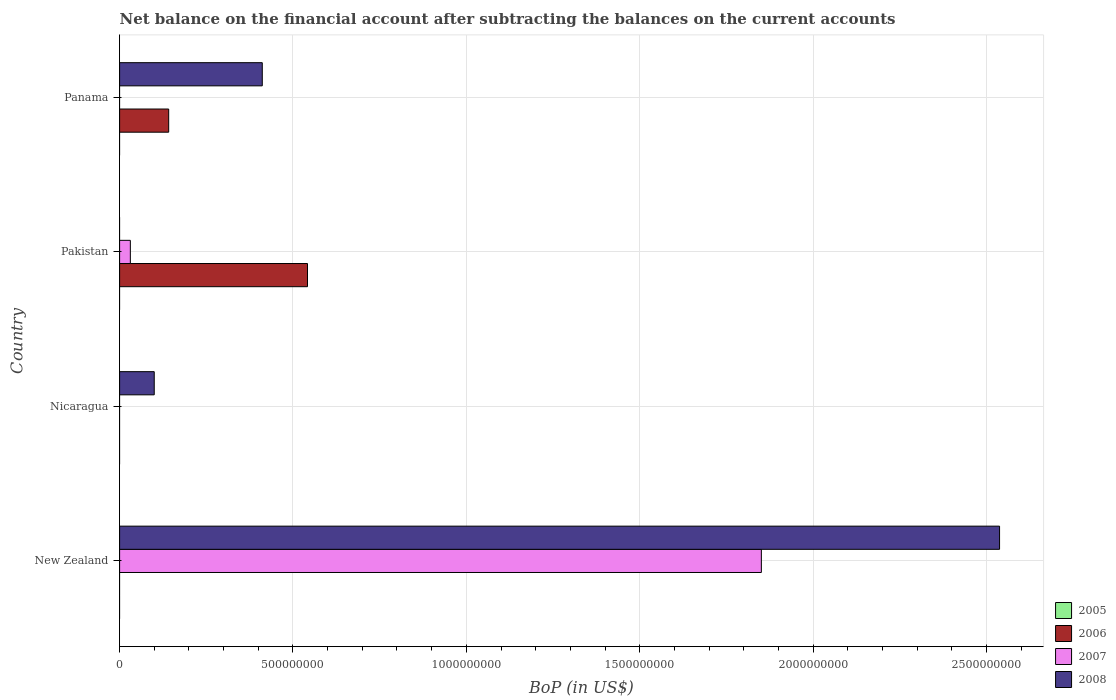How many bars are there on the 2nd tick from the top?
Keep it short and to the point. 2. What is the label of the 4th group of bars from the top?
Give a very brief answer. New Zealand. In how many cases, is the number of bars for a given country not equal to the number of legend labels?
Ensure brevity in your answer.  4. What is the Balance of Payments in 2006 in Nicaragua?
Keep it short and to the point. 0. Across all countries, what is the maximum Balance of Payments in 2007?
Offer a very short reply. 1.85e+09. In which country was the Balance of Payments in 2007 maximum?
Your answer should be compact. New Zealand. What is the total Balance of Payments in 2007 in the graph?
Provide a succinct answer. 1.88e+09. What is the difference between the Balance of Payments in 2006 in Pakistan and that in Panama?
Ensure brevity in your answer.  4.00e+08. What is the difference between the Balance of Payments in 2006 in Panama and the Balance of Payments in 2007 in Pakistan?
Offer a terse response. 1.11e+08. What is the average Balance of Payments in 2008 per country?
Offer a terse response. 7.62e+08. What is the difference between the Balance of Payments in 2007 and Balance of Payments in 2008 in New Zealand?
Provide a succinct answer. -6.87e+08. What is the difference between the highest and the second highest Balance of Payments in 2008?
Make the answer very short. 2.13e+09. What is the difference between the highest and the lowest Balance of Payments in 2008?
Your response must be concise. 2.54e+09. Is it the case that in every country, the sum of the Balance of Payments in 2007 and Balance of Payments in 2008 is greater than the Balance of Payments in 2006?
Ensure brevity in your answer.  No. Are all the bars in the graph horizontal?
Provide a short and direct response. Yes. Are the values on the major ticks of X-axis written in scientific E-notation?
Ensure brevity in your answer.  No. Does the graph contain any zero values?
Offer a terse response. Yes. Does the graph contain grids?
Provide a succinct answer. Yes. What is the title of the graph?
Provide a succinct answer. Net balance on the financial account after subtracting the balances on the current accounts. Does "2005" appear as one of the legend labels in the graph?
Ensure brevity in your answer.  Yes. What is the label or title of the X-axis?
Your answer should be compact. BoP (in US$). What is the BoP (in US$) in 2007 in New Zealand?
Offer a terse response. 1.85e+09. What is the BoP (in US$) in 2008 in New Zealand?
Your answer should be very brief. 2.54e+09. What is the BoP (in US$) in 2005 in Nicaragua?
Keep it short and to the point. 0. What is the BoP (in US$) in 2008 in Nicaragua?
Provide a succinct answer. 9.99e+07. What is the BoP (in US$) in 2005 in Pakistan?
Your answer should be compact. 0. What is the BoP (in US$) in 2006 in Pakistan?
Keep it short and to the point. 5.42e+08. What is the BoP (in US$) in 2007 in Pakistan?
Offer a terse response. 3.10e+07. What is the BoP (in US$) in 2005 in Panama?
Provide a short and direct response. 0. What is the BoP (in US$) of 2006 in Panama?
Offer a terse response. 1.42e+08. What is the BoP (in US$) in 2008 in Panama?
Provide a short and direct response. 4.12e+08. Across all countries, what is the maximum BoP (in US$) in 2006?
Provide a succinct answer. 5.42e+08. Across all countries, what is the maximum BoP (in US$) of 2007?
Offer a terse response. 1.85e+09. Across all countries, what is the maximum BoP (in US$) of 2008?
Provide a succinct answer. 2.54e+09. Across all countries, what is the minimum BoP (in US$) in 2006?
Offer a very short reply. 0. Across all countries, what is the minimum BoP (in US$) of 2007?
Make the answer very short. 0. Across all countries, what is the minimum BoP (in US$) in 2008?
Your answer should be very brief. 0. What is the total BoP (in US$) of 2005 in the graph?
Provide a short and direct response. 0. What is the total BoP (in US$) of 2006 in the graph?
Ensure brevity in your answer.  6.84e+08. What is the total BoP (in US$) of 2007 in the graph?
Provide a succinct answer. 1.88e+09. What is the total BoP (in US$) of 2008 in the graph?
Your answer should be compact. 3.05e+09. What is the difference between the BoP (in US$) of 2008 in New Zealand and that in Nicaragua?
Offer a terse response. 2.44e+09. What is the difference between the BoP (in US$) of 2007 in New Zealand and that in Pakistan?
Your answer should be very brief. 1.82e+09. What is the difference between the BoP (in US$) in 2008 in New Zealand and that in Panama?
Give a very brief answer. 2.13e+09. What is the difference between the BoP (in US$) of 2008 in Nicaragua and that in Panama?
Provide a succinct answer. -3.12e+08. What is the difference between the BoP (in US$) of 2006 in Pakistan and that in Panama?
Offer a very short reply. 4.00e+08. What is the difference between the BoP (in US$) in 2007 in New Zealand and the BoP (in US$) in 2008 in Nicaragua?
Your answer should be very brief. 1.75e+09. What is the difference between the BoP (in US$) of 2007 in New Zealand and the BoP (in US$) of 2008 in Panama?
Provide a succinct answer. 1.44e+09. What is the difference between the BoP (in US$) in 2006 in Pakistan and the BoP (in US$) in 2008 in Panama?
Provide a short and direct response. 1.30e+08. What is the difference between the BoP (in US$) of 2007 in Pakistan and the BoP (in US$) of 2008 in Panama?
Ensure brevity in your answer.  -3.80e+08. What is the average BoP (in US$) in 2006 per country?
Your answer should be compact. 1.71e+08. What is the average BoP (in US$) of 2007 per country?
Ensure brevity in your answer.  4.70e+08. What is the average BoP (in US$) in 2008 per country?
Ensure brevity in your answer.  7.62e+08. What is the difference between the BoP (in US$) in 2007 and BoP (in US$) in 2008 in New Zealand?
Provide a succinct answer. -6.87e+08. What is the difference between the BoP (in US$) of 2006 and BoP (in US$) of 2007 in Pakistan?
Provide a succinct answer. 5.11e+08. What is the difference between the BoP (in US$) of 2006 and BoP (in US$) of 2008 in Panama?
Your answer should be compact. -2.70e+08. What is the ratio of the BoP (in US$) of 2008 in New Zealand to that in Nicaragua?
Your response must be concise. 25.4. What is the ratio of the BoP (in US$) of 2007 in New Zealand to that in Pakistan?
Provide a succinct answer. 59.71. What is the ratio of the BoP (in US$) of 2008 in New Zealand to that in Panama?
Provide a short and direct response. 6.17. What is the ratio of the BoP (in US$) of 2008 in Nicaragua to that in Panama?
Provide a succinct answer. 0.24. What is the ratio of the BoP (in US$) of 2006 in Pakistan to that in Panama?
Offer a very short reply. 3.83. What is the difference between the highest and the second highest BoP (in US$) in 2008?
Offer a very short reply. 2.13e+09. What is the difference between the highest and the lowest BoP (in US$) in 2006?
Provide a succinct answer. 5.42e+08. What is the difference between the highest and the lowest BoP (in US$) in 2007?
Offer a very short reply. 1.85e+09. What is the difference between the highest and the lowest BoP (in US$) in 2008?
Your answer should be very brief. 2.54e+09. 